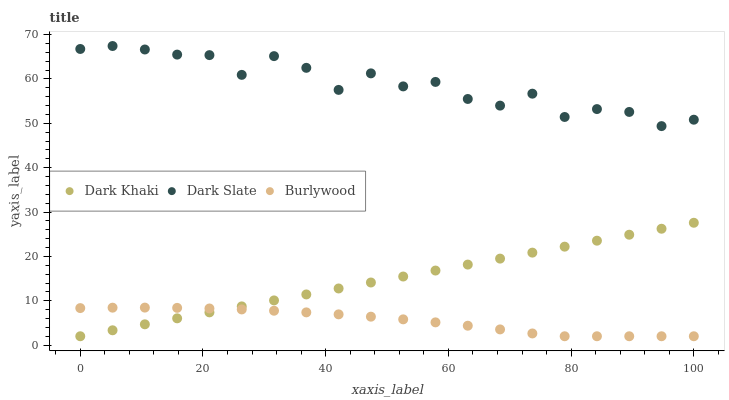Does Burlywood have the minimum area under the curve?
Answer yes or no. Yes. Does Dark Slate have the maximum area under the curve?
Answer yes or no. Yes. Does Dark Slate have the minimum area under the curve?
Answer yes or no. No. Does Burlywood have the maximum area under the curve?
Answer yes or no. No. Is Dark Khaki the smoothest?
Answer yes or no. Yes. Is Dark Slate the roughest?
Answer yes or no. Yes. Is Burlywood the smoothest?
Answer yes or no. No. Is Burlywood the roughest?
Answer yes or no. No. Does Dark Khaki have the lowest value?
Answer yes or no. Yes. Does Dark Slate have the lowest value?
Answer yes or no. No. Does Dark Slate have the highest value?
Answer yes or no. Yes. Does Burlywood have the highest value?
Answer yes or no. No. Is Dark Khaki less than Dark Slate?
Answer yes or no. Yes. Is Dark Slate greater than Dark Khaki?
Answer yes or no. Yes. Does Burlywood intersect Dark Khaki?
Answer yes or no. Yes. Is Burlywood less than Dark Khaki?
Answer yes or no. No. Is Burlywood greater than Dark Khaki?
Answer yes or no. No. Does Dark Khaki intersect Dark Slate?
Answer yes or no. No. 